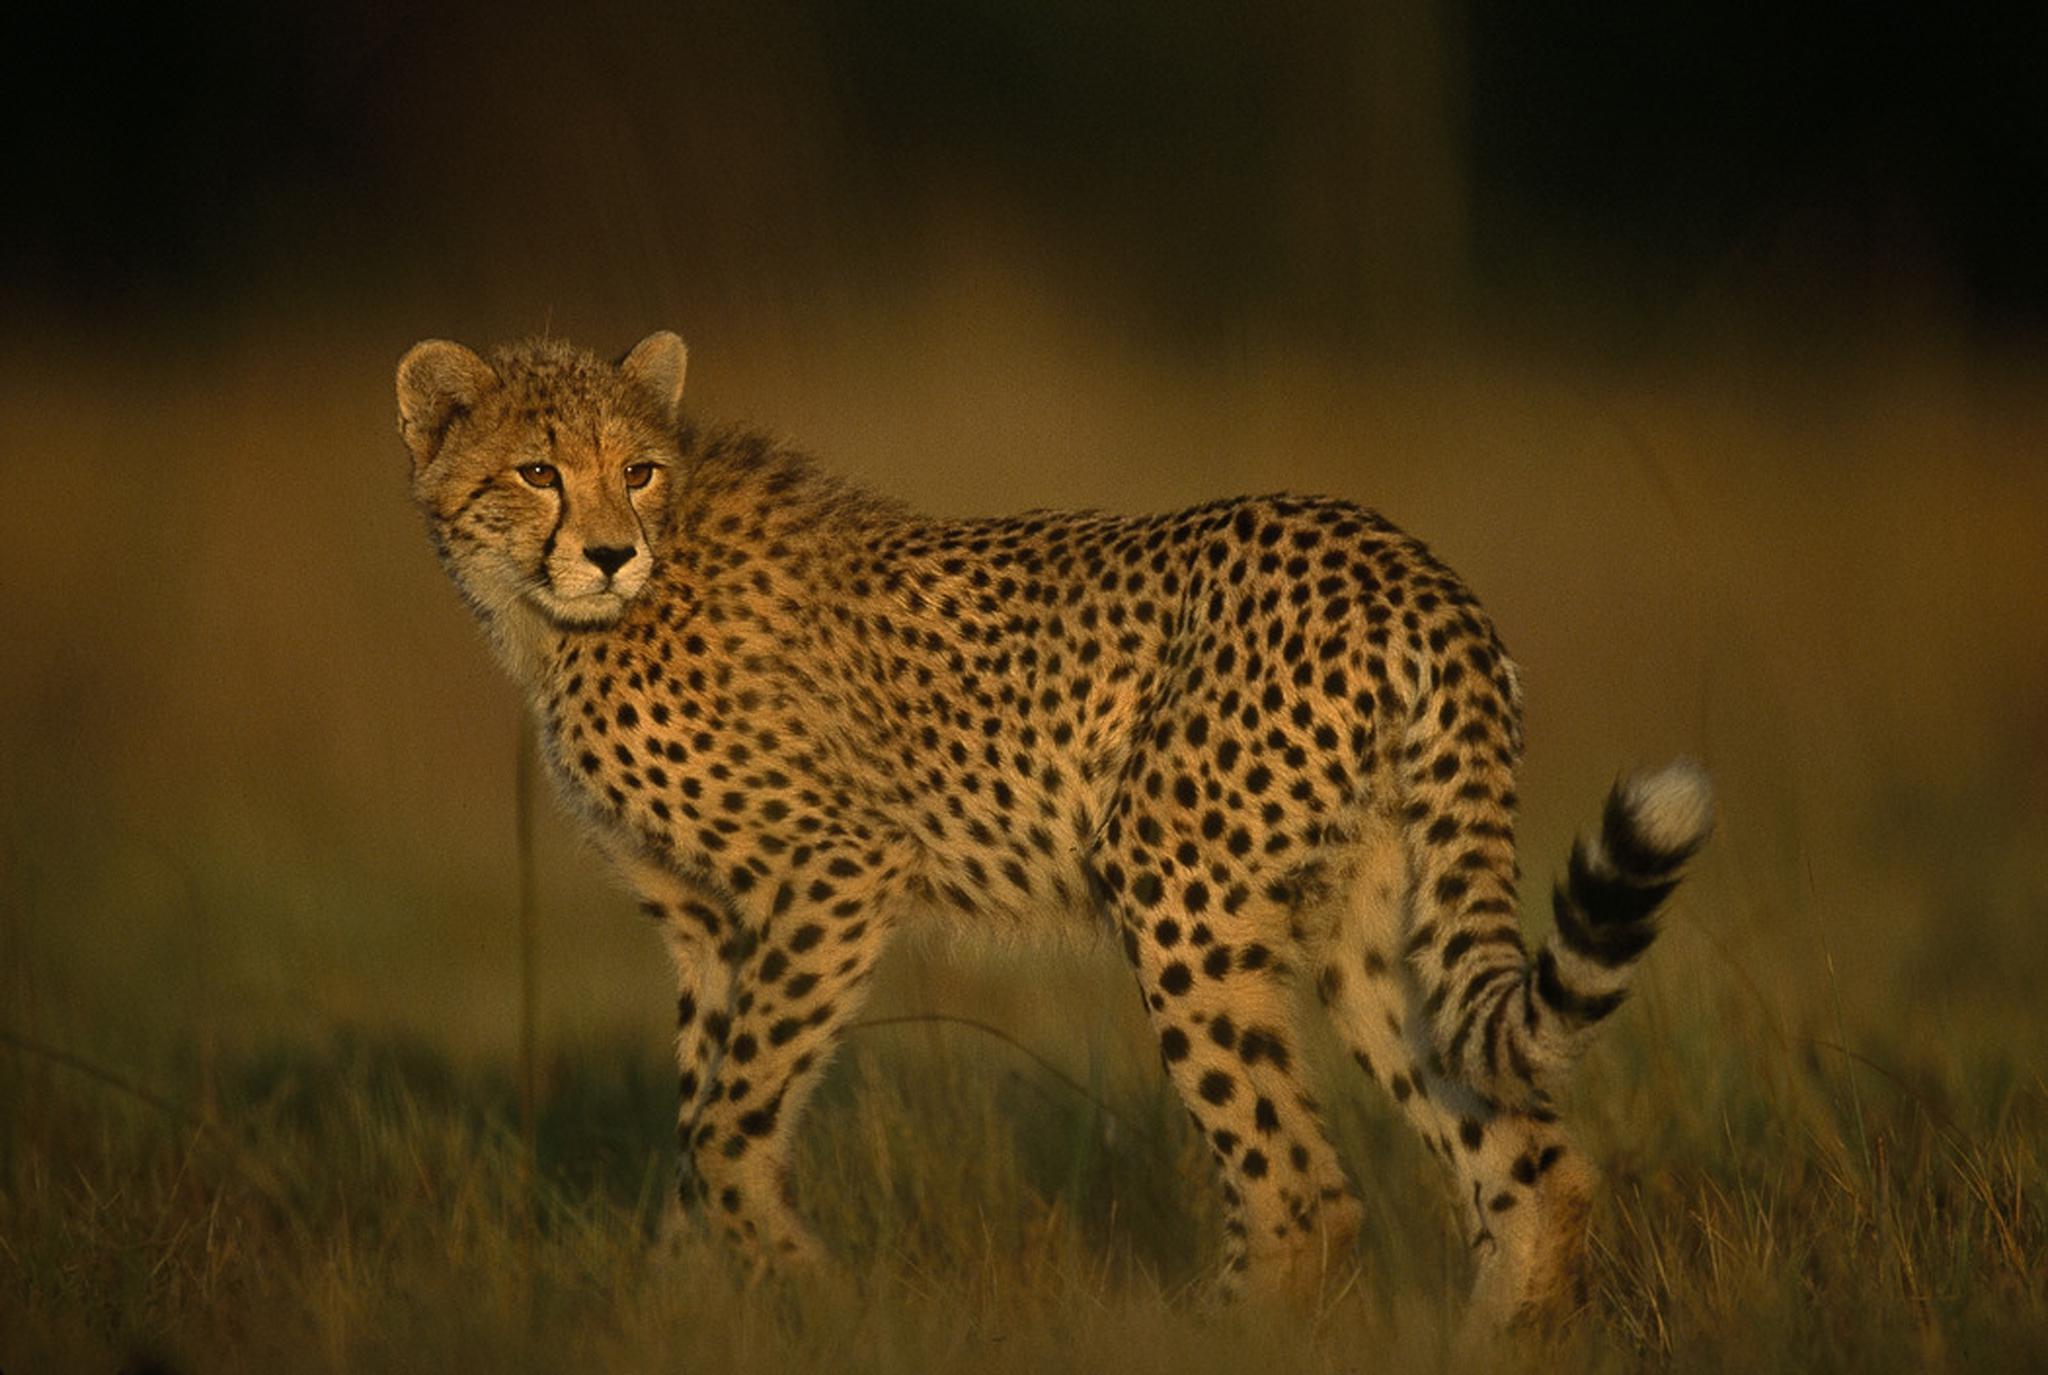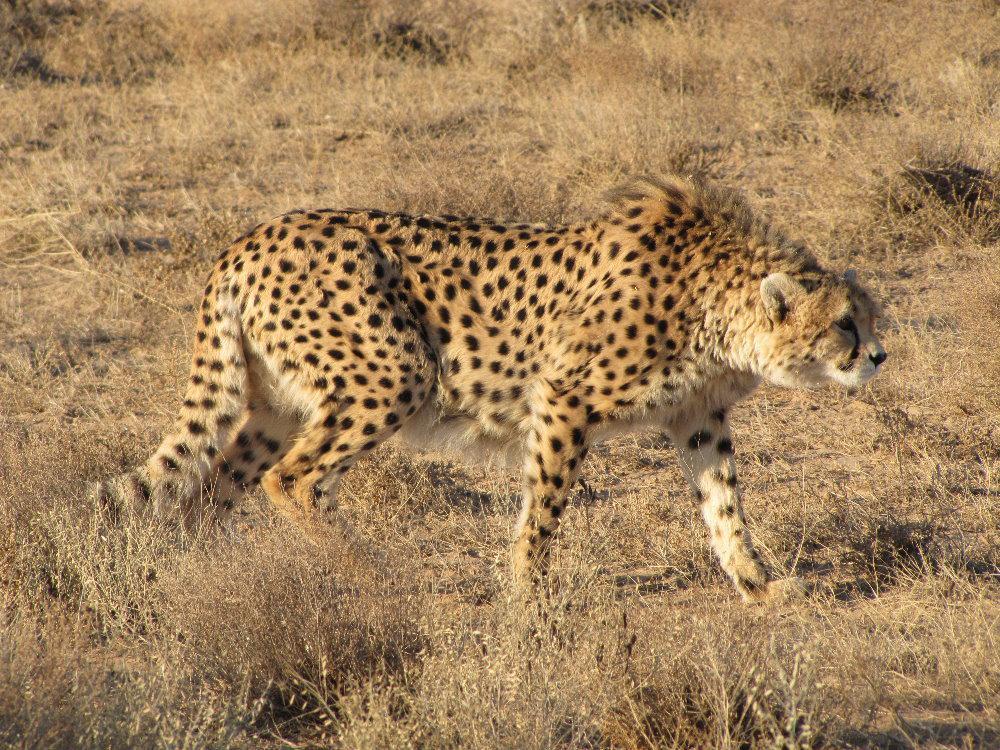The first image is the image on the left, the second image is the image on the right. Considering the images on both sides, is "There is a single cheetah running in the left image." valid? Answer yes or no. No. The first image is the image on the left, the second image is the image on the right. Given the left and right images, does the statement "Not more than one cheetah in any of the pictures" hold true? Answer yes or no. Yes. 